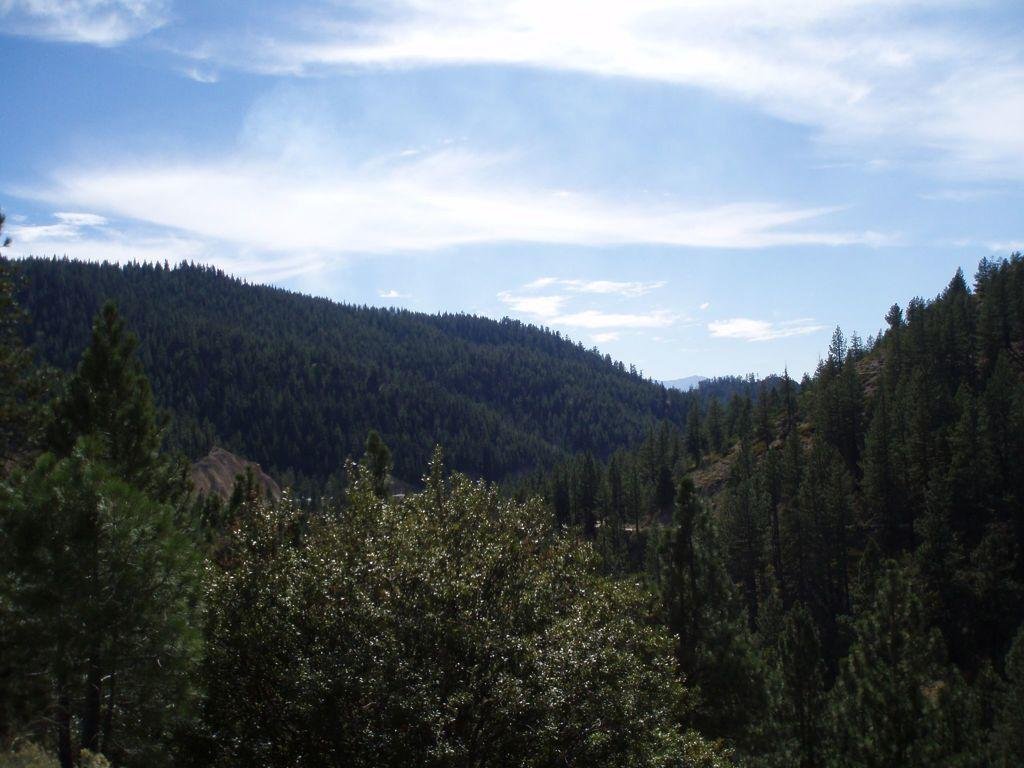What type of vegetation can be seen in the image? There are trees in the image. What can be seen in the distance in the image? There are hills in the background of the image. What is visible in the sky in the background of the image? There are clouds in the sky in the background of the image. Where is the coach located in the image? There is no coach present in the image. How many deer can be seen in the image? There are no deer present in the image. 